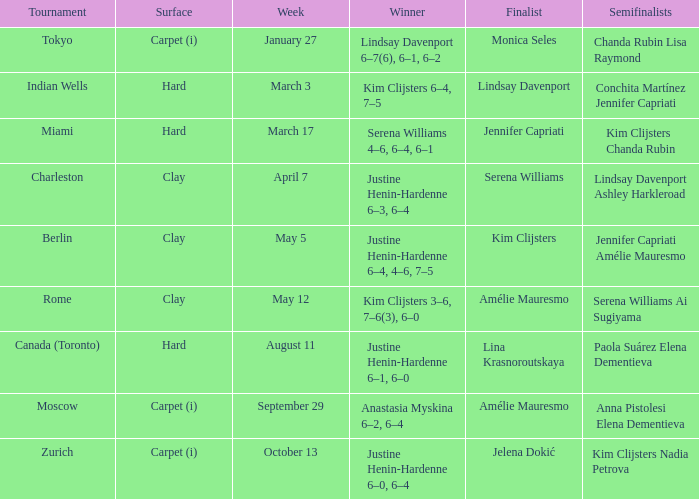Who claimed victory over lindsay davenport? Kim Clijsters 6–4, 7–5. 